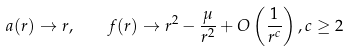Convert formula to latex. <formula><loc_0><loc_0><loc_500><loc_500>a ( r ) \rightarrow r , \quad f ( r ) \rightarrow r ^ { 2 } - \frac { \mu } { r ^ { 2 } } + O \left ( \frac { 1 } { r ^ { c } } \right ) , c \geq 2</formula> 